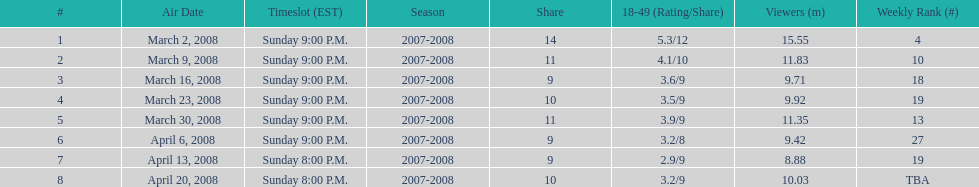How many shows had at least 10 million viewers? 4. 